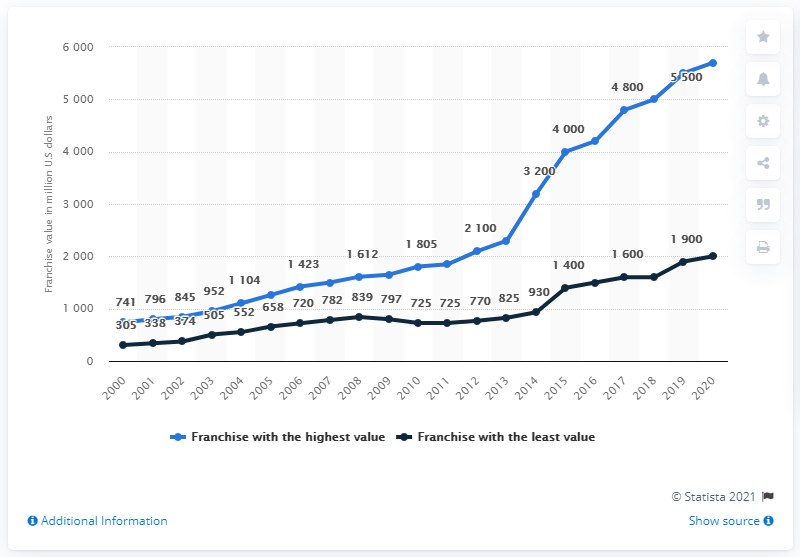Identify some key points in this picture. In 2020, the Dallas Cowboys had a value of approximately 5,700 dollars. 